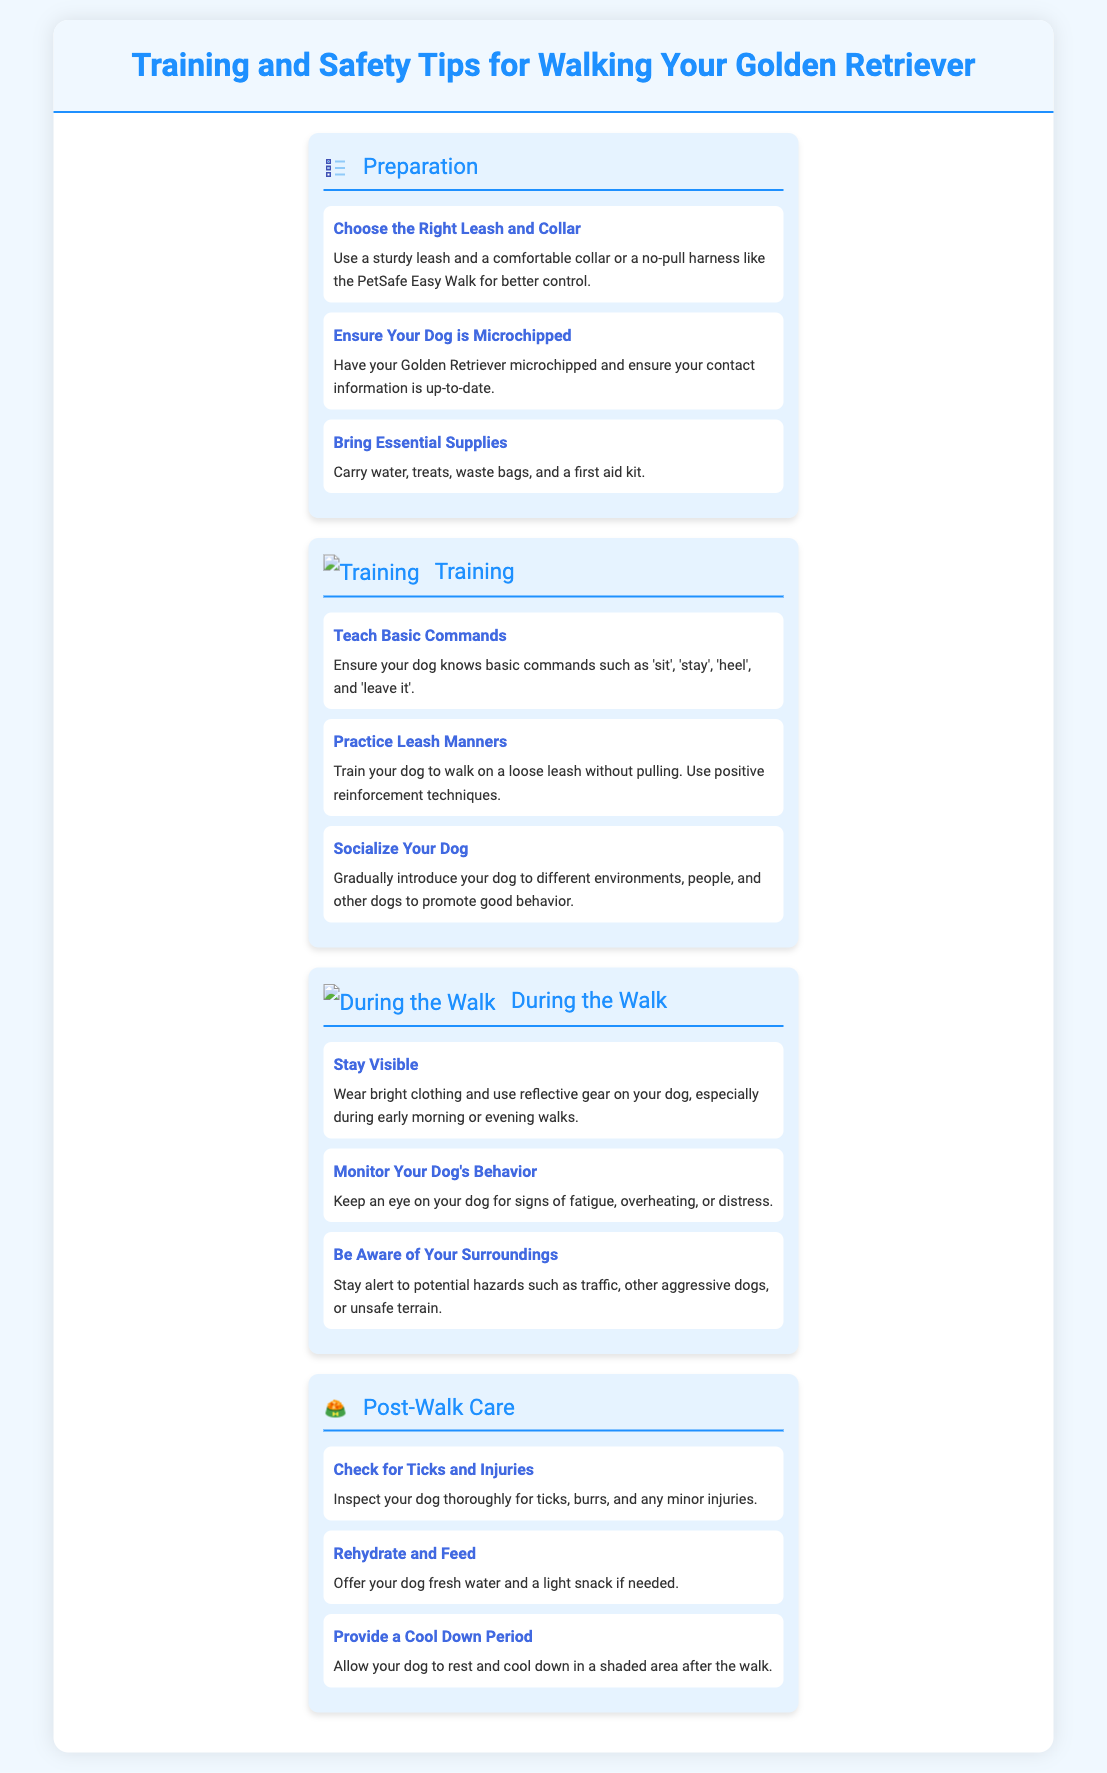What should you use for better control? The document suggests using a sturdy leash and a comfortable collar or a no-pull harness for better control.
Answer: A sturdy leash and a comfortable collar or a no-pull harness How can you ensure your dog is safe? The document states that having your Golden Retriever microchipped helps ensure safety by keeping your contact information up to date.
Answer: Microchipped What items should you bring during a walk? Essential supplies to carry according to the document include water, treats, waste bags, and a first aid kit.
Answer: Water, treats, waste bags, first aid kit Which command is essential for walking? Basic commands essential for walking include 'sit', 'stay', 'heel', and 'leave it'.
Answer: 'sit', 'stay', 'heel', 'leave it' What color clothing should you wear while walking? The document recommends wearing bright clothing during walks to stay visible.
Answer: Bright clothing How should you monitor your dog's condition? According to the document, you should keep an eye on your dog for signs of fatigue, overheating, or distress.
Answer: Fatigue, overheating, distress What should you check for after a walk? The document suggests checking for ticks, burrs, and minor injuries after a walk.
Answer: Ticks, burrs, minor injuries What is suggested to offer your dog after a walk? The document suggests offering your dog fresh water and a light snack after the walk.
Answer: Fresh water and a light snack How can you ensure your dog remains calm during walks? The document emphasizes practicing leash manners and using positive reinforcement techniques to ensure your dog's calmness.
Answer: Positive reinforcement techniques 